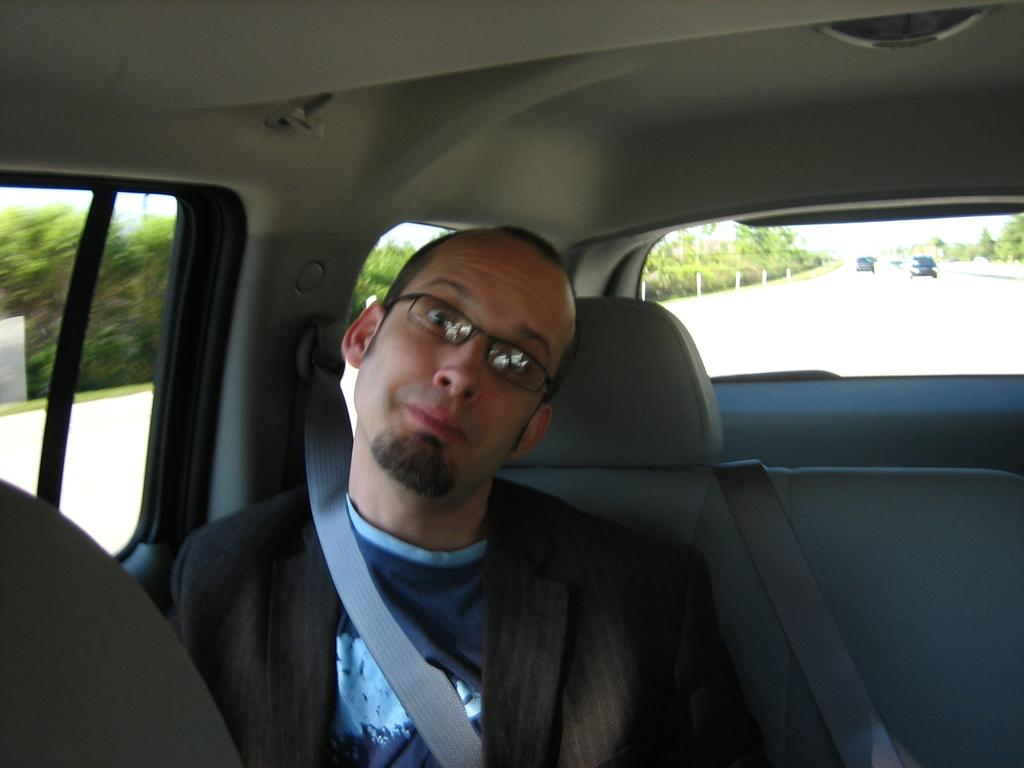Where was the image taken? The image was taken inside a car. What can be seen inside the car? There is a person sitting in the car. Is the person following any safety precautions? Yes, the person is wearing a seat belt. What is visible through the car window? Trees are visible through the car window. What can be seen behind the car? There are other cars visible behind the car. Can you see a baseball game happening outside the car window? No, there is no baseball game visible through the car window; trees are the only visible element. 